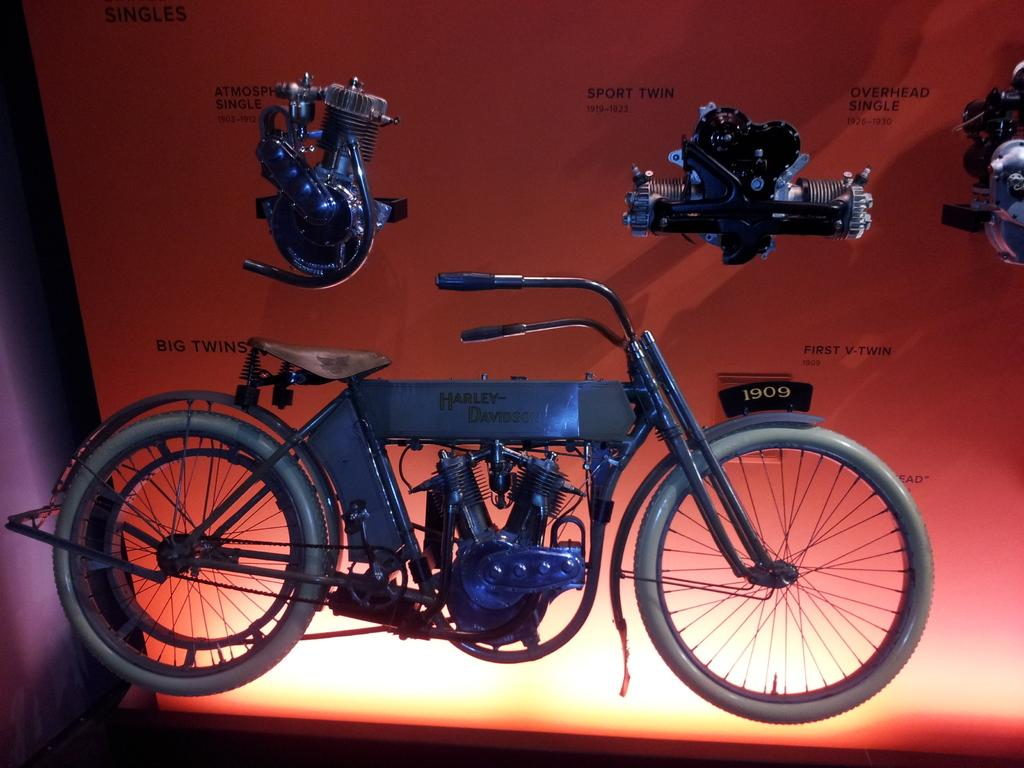What is the main subject of the image? The main subject of the image is a vehicle. What can be seen on the vehicle? There is text written on the vehicle. What else is visible in the image related to the vehicle? There are parts of a vehicle visible in the background. What is present in the background with text on it? There is a board with text written on it in the background. What type of man is depicted on the vehicle in the image? There is no man depicted on the vehicle in the image; it only has text written on it. 